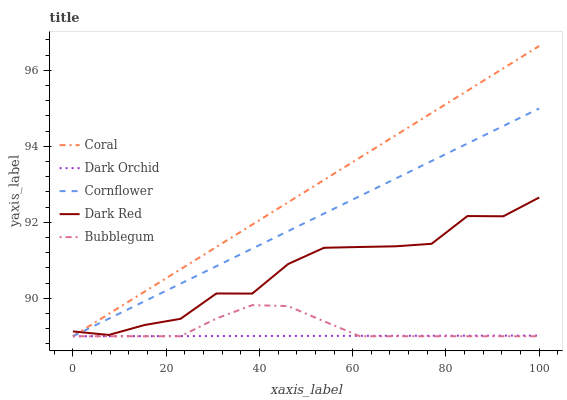Does Dark Orchid have the minimum area under the curve?
Answer yes or no. Yes. Does Coral have the maximum area under the curve?
Answer yes or no. Yes. Does Bubblegum have the minimum area under the curve?
Answer yes or no. No. Does Bubblegum have the maximum area under the curve?
Answer yes or no. No. Is Coral the smoothest?
Answer yes or no. Yes. Is Dark Red the roughest?
Answer yes or no. Yes. Is Bubblegum the smoothest?
Answer yes or no. No. Is Bubblegum the roughest?
Answer yes or no. No. Does Dark Red have the lowest value?
Answer yes or no. No. Does Coral have the highest value?
Answer yes or no. Yes. Does Bubblegum have the highest value?
Answer yes or no. No. Is Bubblegum less than Dark Red?
Answer yes or no. Yes. Is Dark Red greater than Dark Orchid?
Answer yes or no. Yes. Does Bubblegum intersect Dark Red?
Answer yes or no. No. 